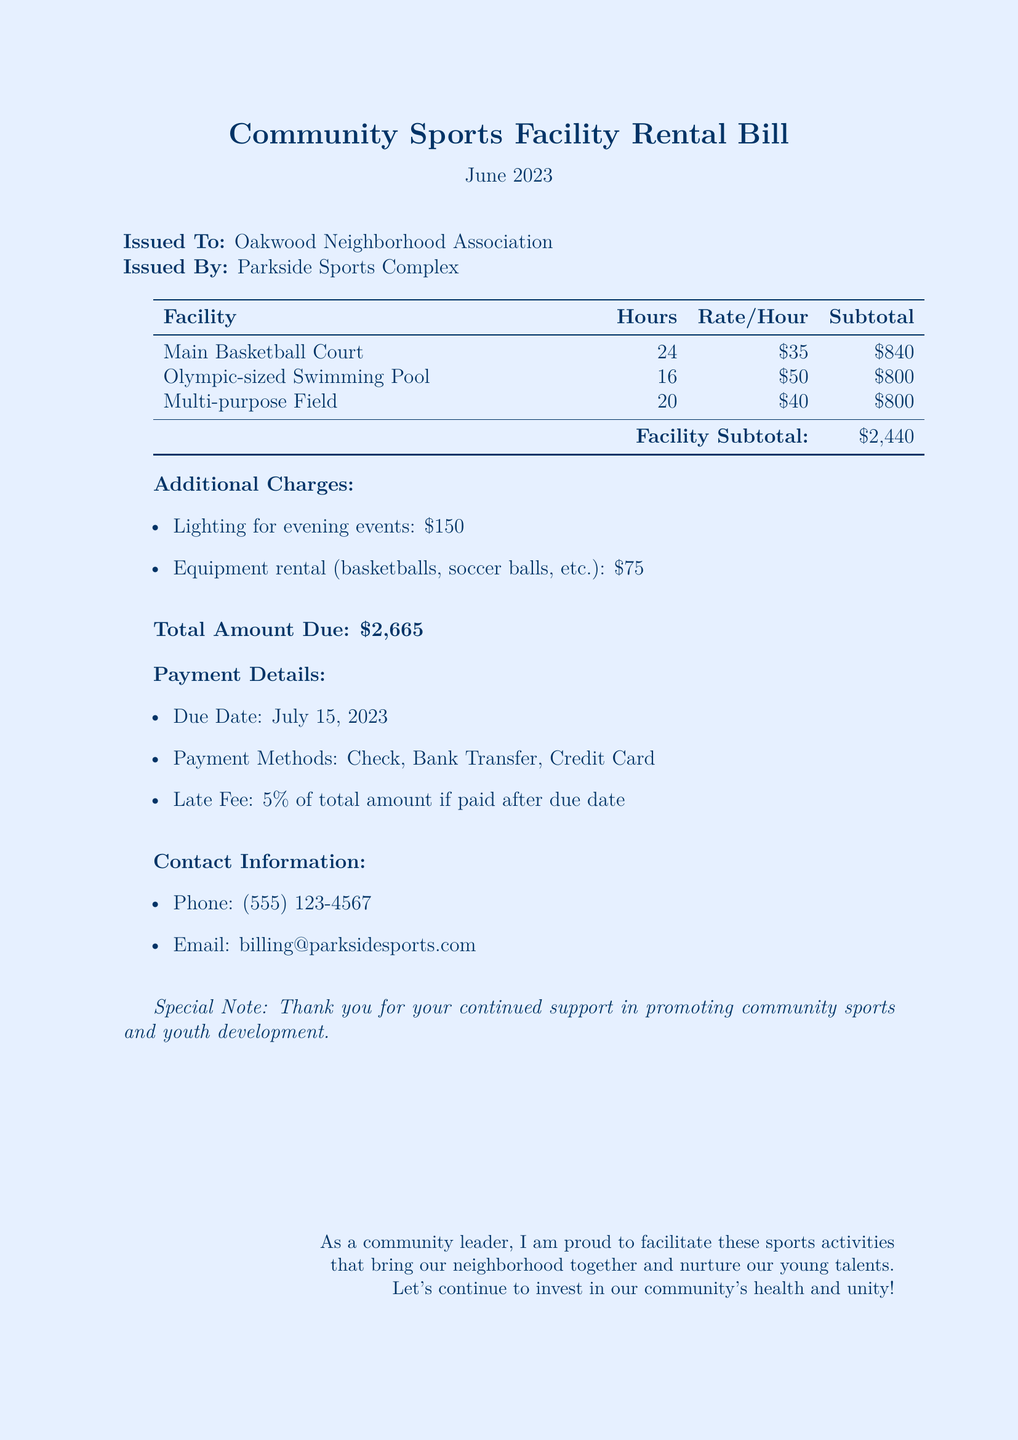What is the issued date of the bill? The issued date is specifically listed in the document, which is June 2023.
Answer: June 2023 Who is the bill issued to? The bill clearly states that it is issued to the Oakwood Neighborhood Association.
Answer: Oakwood Neighborhood Association What is the total amount due? The document provides a specific total, which is the sum of facility charges and additional charges.
Answer: $2,665 How many hours was the Main Basketball Court used? The document indicates that the Main Basketball Court was used for 24 hours.
Answer: 24 What is the late fee percentage if paid after the due date? The late fee percentage is specified as 5 percent of the total amount.
Answer: 5% What is the rate per hour for the Olympic-sized Swimming Pool? The document lists the rate per hour for the Swimming Pool as $50.
Answer: $50 What is the subtotal for the Multi-purpose Field? The subtotal for the Multi-purpose Field is distinctly stated in the table as $800.
Answer: $800 What additional charge is listed for equipment rental? The document specifies that the equipment rental charge is $75.
Answer: $75 What payment methods are available? The document includes multiple payment methods, explicitly mentioning Check, Bank Transfer, and Credit Card.
Answer: Check, Bank Transfer, Credit Card 